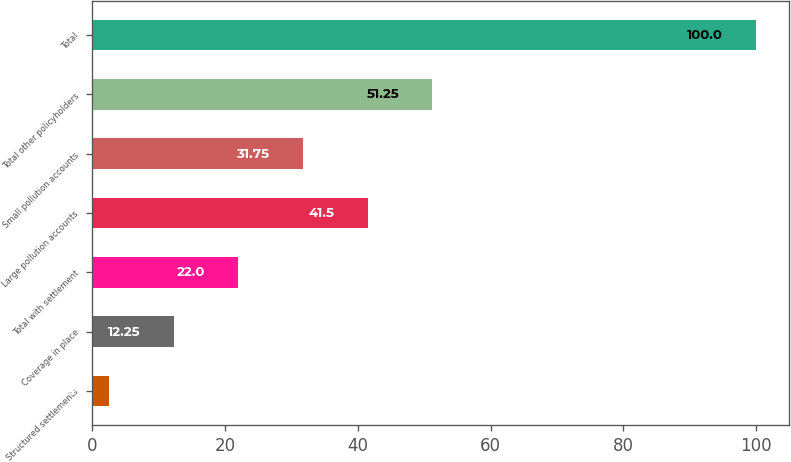Convert chart. <chart><loc_0><loc_0><loc_500><loc_500><bar_chart><fcel>Structured settlements<fcel>Coverage in place<fcel>Total with settlement<fcel>Large pollution accounts<fcel>Small pollution accounts<fcel>Total other policyholders<fcel>Total<nl><fcel>2.5<fcel>12.25<fcel>22<fcel>41.5<fcel>31.75<fcel>51.25<fcel>100<nl></chart> 